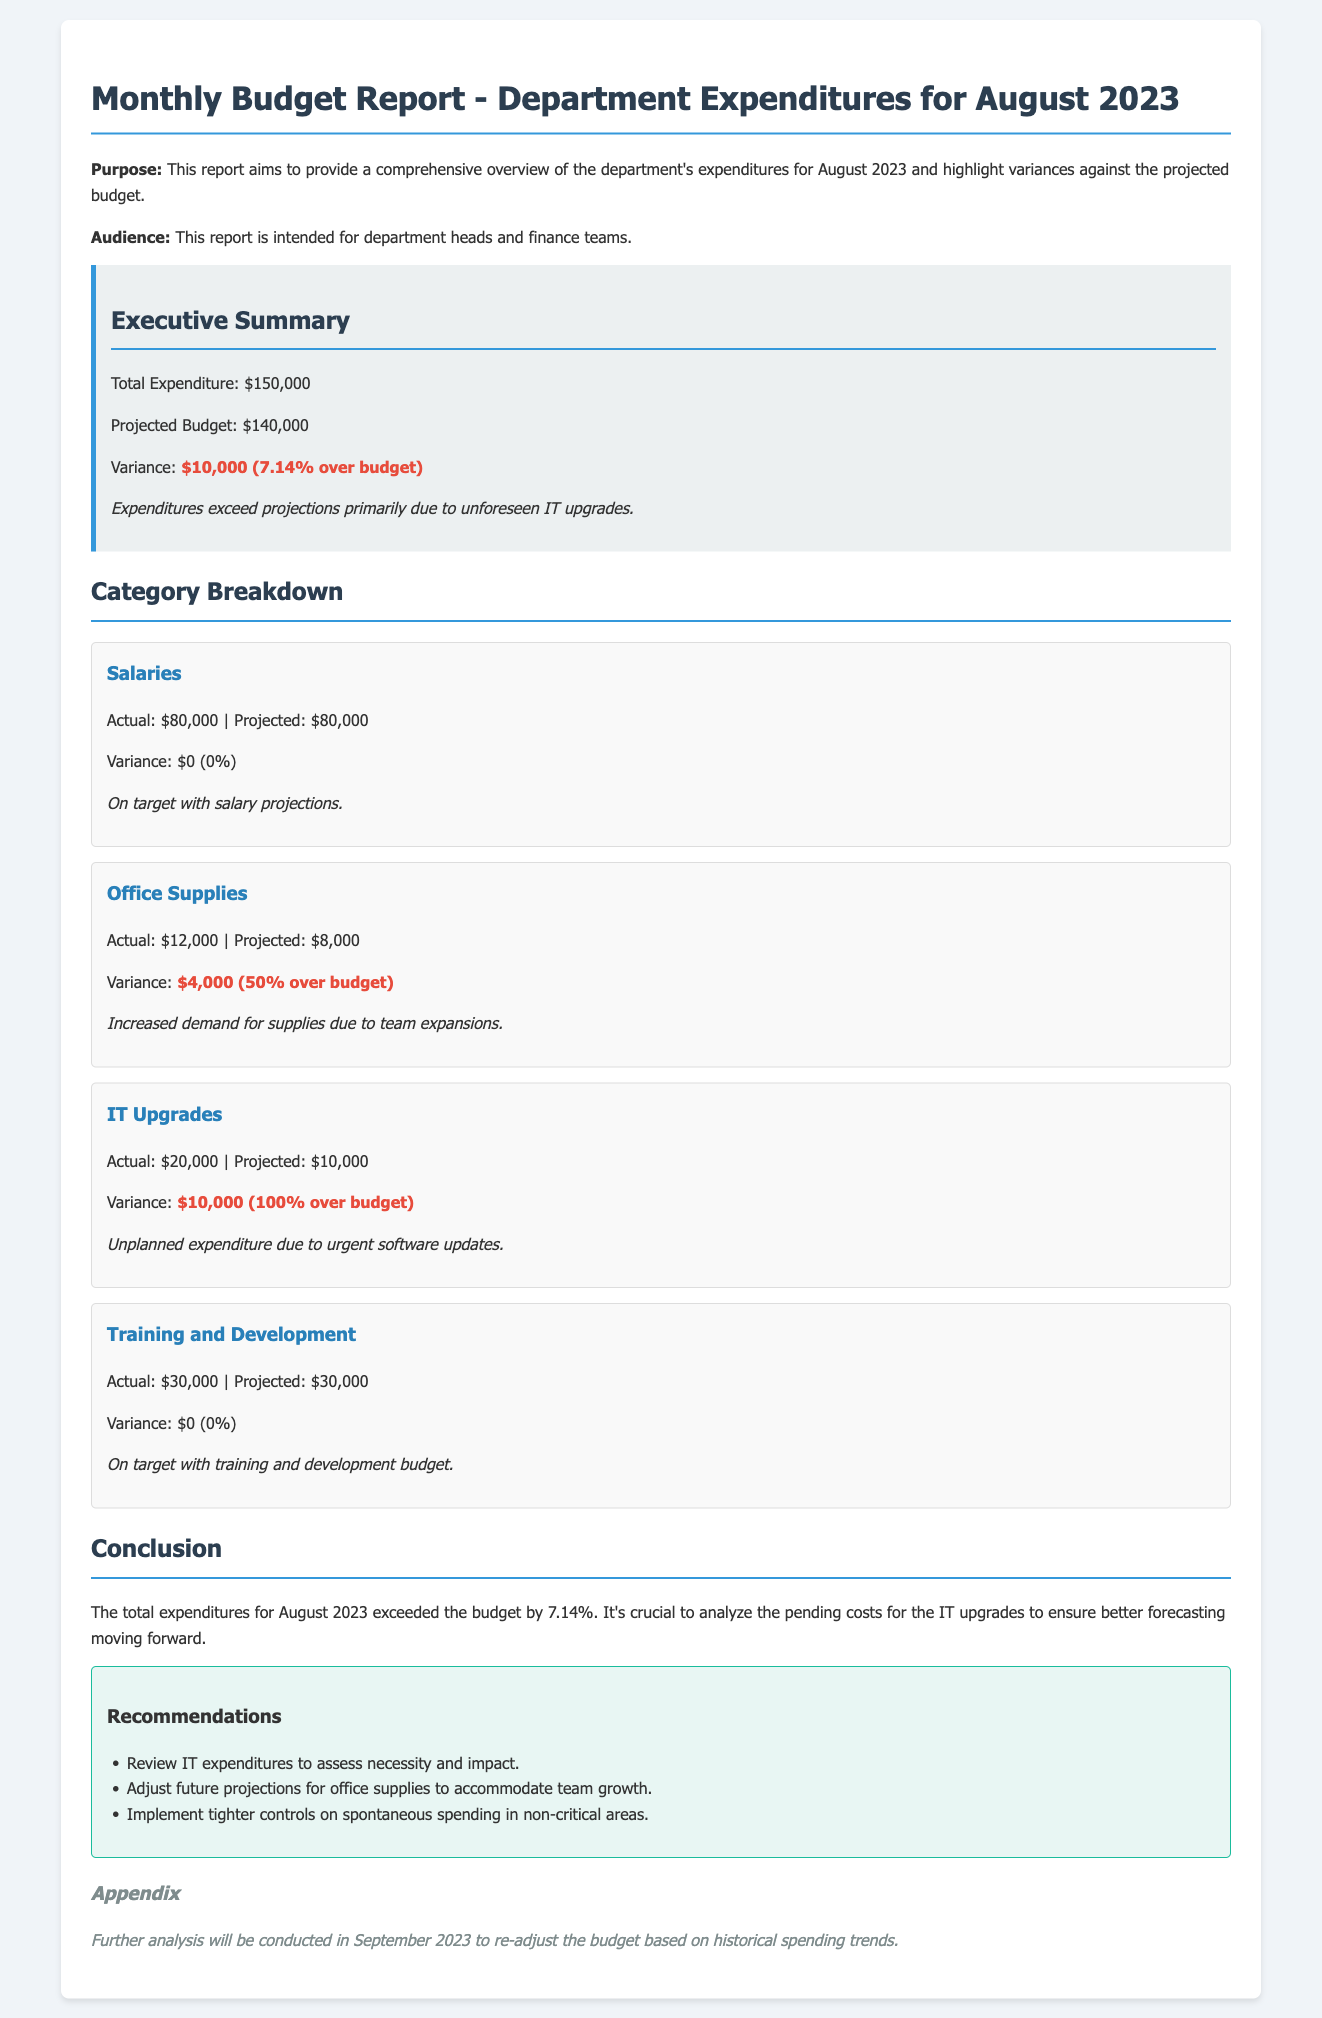What is the total expenditure for August 2023? The total expenditure is explicitly stated in the executive summary of the report.
Answer: $150,000 What was the projected budget for August 2023? The projected budget is also mentioned in the executive summary section.
Answer: $140,000 What is the variance against the projected budget? The variance is highlighted in the executive summary as a specific amount.
Answer: $10,000 (7.14% over budget) What was the actual expenditure for IT upgrades? The actual expenditure for IT upgrades can be found in the category breakdown section.
Answer: $20,000 What was the projected expenditure for Office Supplies? The projected expenditure for Office Supplies is provided in the category breakdown.
Answer: $8,000 Why did the Office Supplies expenditures exceed projections? The reason for the variance in Office Supplies is mentioned in the corresponding category section.
Answer: Increased demand for supplies due to team expansions What are the recommendations regarding IT expenditures? The recommendations are provided in a specific section dedicated to recommendations.
Answer: Review IT expenditures to assess necessity and impact Which category had no variance in expenditures? The category with no variance can be identified by comparing actual and projected expenditures in the document.
Answer: Salaries What further analysis will be conducted in September 2023? The planned future analysis is mentioned in the appendix section of the report.
Answer: Re-adjust the budget based on historical spending trends 